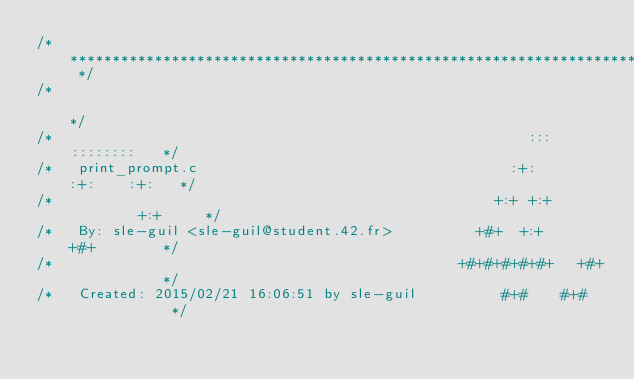<code> <loc_0><loc_0><loc_500><loc_500><_C_>/* ************************************************************************** */
/*                                                                            */
/*                                                        :::      ::::::::   */
/*   print_prompt.c                                     :+:      :+:    :+:   */
/*                                                    +:+ +:+         +:+     */
/*   By: sle-guil <sle-guil@student.42.fr>          +#+  +:+       +#+        */
/*                                                +#+#+#+#+#+   +#+           */
/*   Created: 2015/02/21 16:06:51 by sle-guil          #+#    #+#             */</code> 